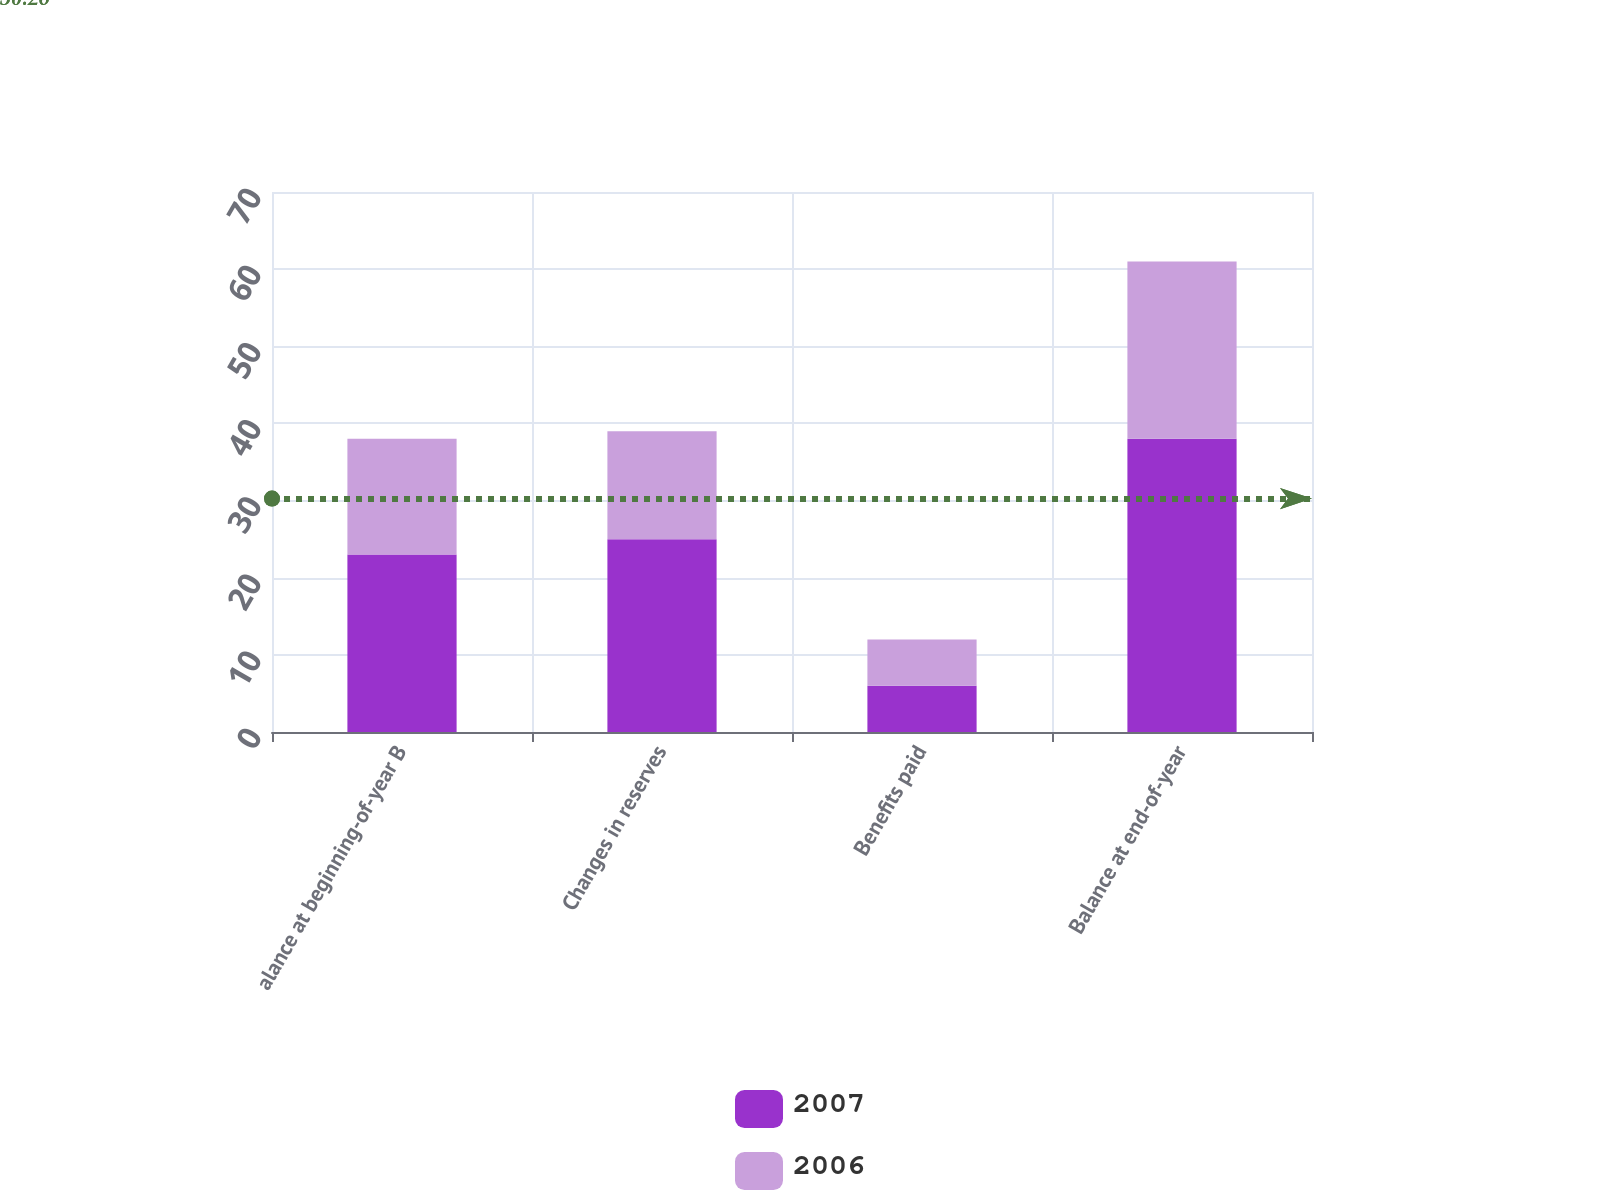Convert chart. <chart><loc_0><loc_0><loc_500><loc_500><stacked_bar_chart><ecel><fcel>alance at beginning-of-year B<fcel>Changes in reserves<fcel>Benefits paid<fcel>Balance at end-of-year<nl><fcel>2007<fcel>23<fcel>25<fcel>6<fcel>38<nl><fcel>2006<fcel>15<fcel>14<fcel>6<fcel>23<nl></chart> 